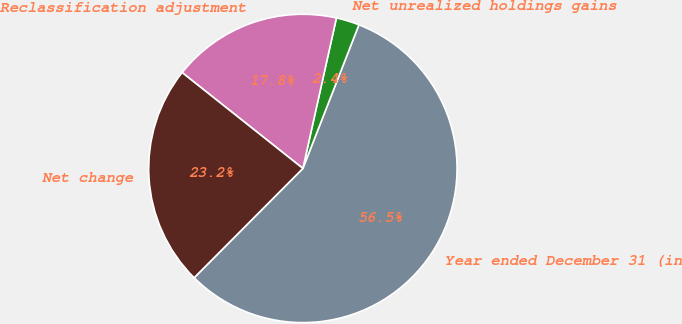Convert chart. <chart><loc_0><loc_0><loc_500><loc_500><pie_chart><fcel>Year ended December 31 (in<fcel>Net unrealized holdings gains<fcel>Reclassification adjustment<fcel>Net change<nl><fcel>56.54%<fcel>2.43%<fcel>17.81%<fcel>23.22%<nl></chart> 